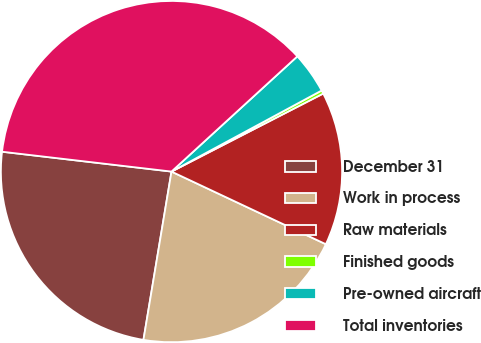Convert chart to OTSL. <chart><loc_0><loc_0><loc_500><loc_500><pie_chart><fcel>December 31<fcel>Work in process<fcel>Raw materials<fcel>Finished goods<fcel>Pre-owned aircraft<fcel>Total inventories<nl><fcel>24.23%<fcel>20.63%<fcel>14.56%<fcel>0.32%<fcel>3.92%<fcel>36.35%<nl></chart> 